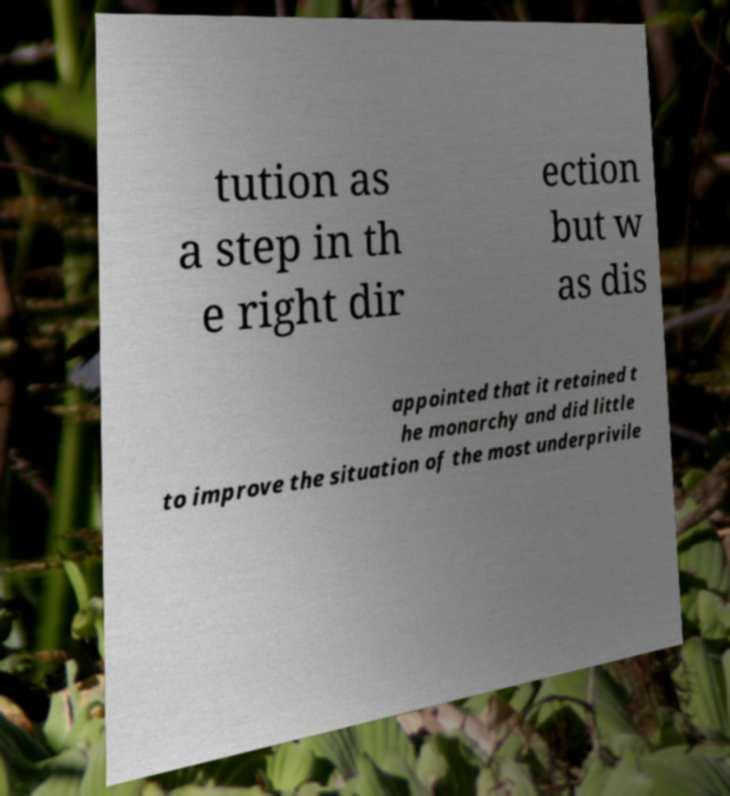Please read and relay the text visible in this image. What does it say? tution as a step in th e right dir ection but w as dis appointed that it retained t he monarchy and did little to improve the situation of the most underprivile 